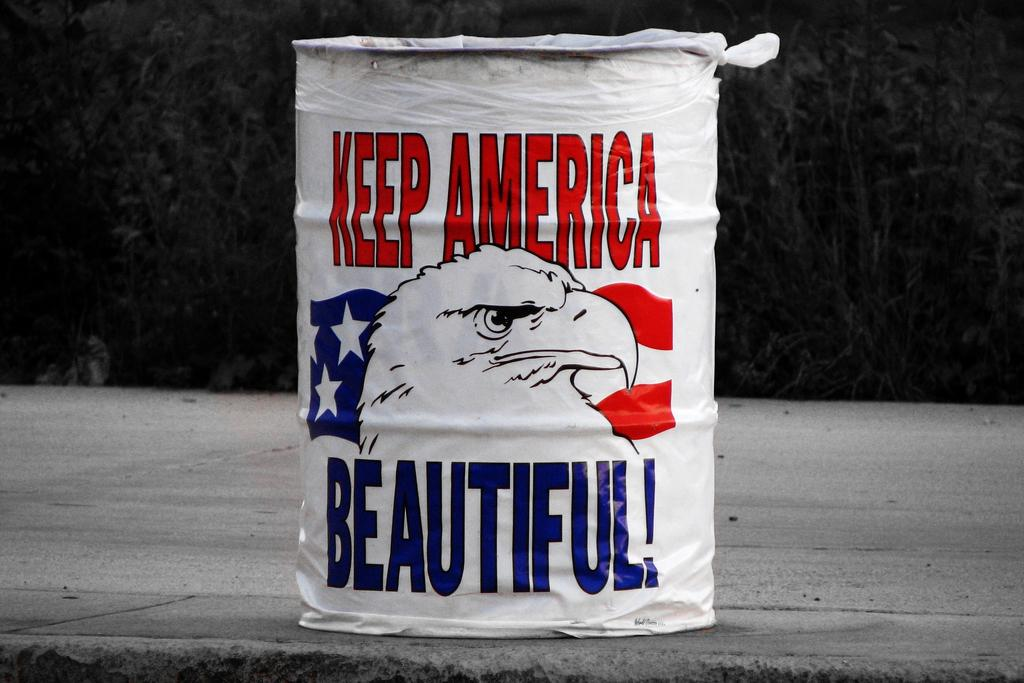<image>
Offer a succinct explanation of the picture presented. An object is wrapped in white plastic that says Keep America Beautiful. 